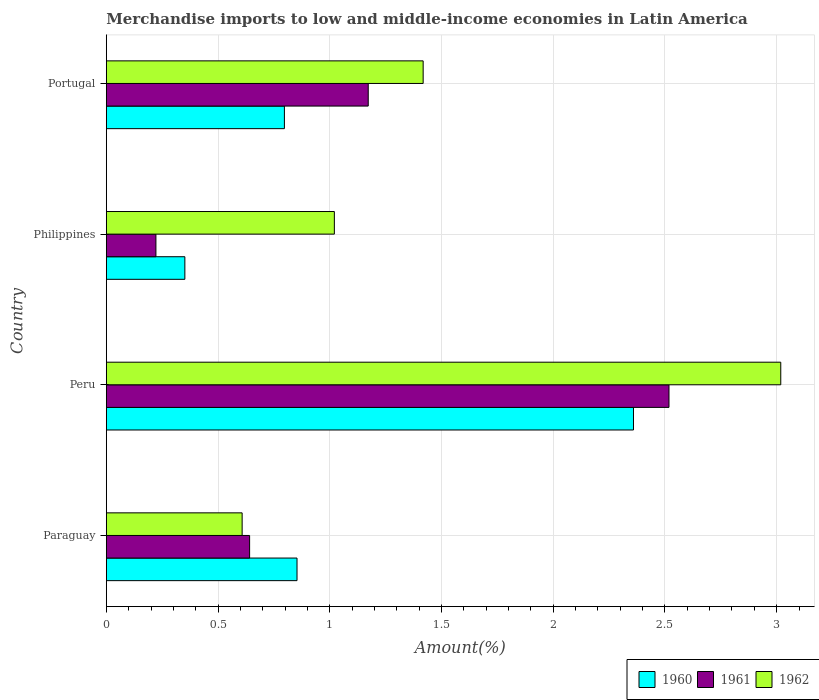Are the number of bars per tick equal to the number of legend labels?
Offer a very short reply. Yes. How many bars are there on the 1st tick from the bottom?
Provide a short and direct response. 3. In how many cases, is the number of bars for a given country not equal to the number of legend labels?
Provide a succinct answer. 0. What is the percentage of amount earned from merchandise imports in 1962 in Peru?
Give a very brief answer. 3.02. Across all countries, what is the maximum percentage of amount earned from merchandise imports in 1961?
Your answer should be compact. 2.52. Across all countries, what is the minimum percentage of amount earned from merchandise imports in 1960?
Your answer should be very brief. 0.35. What is the total percentage of amount earned from merchandise imports in 1961 in the graph?
Provide a succinct answer. 4.55. What is the difference between the percentage of amount earned from merchandise imports in 1961 in Philippines and that in Portugal?
Your answer should be compact. -0.95. What is the difference between the percentage of amount earned from merchandise imports in 1961 in Peru and the percentage of amount earned from merchandise imports in 1960 in Paraguay?
Provide a short and direct response. 1.66. What is the average percentage of amount earned from merchandise imports in 1960 per country?
Provide a succinct answer. 1.09. What is the difference between the percentage of amount earned from merchandise imports in 1961 and percentage of amount earned from merchandise imports in 1962 in Portugal?
Keep it short and to the point. -0.25. What is the ratio of the percentage of amount earned from merchandise imports in 1960 in Paraguay to that in Peru?
Make the answer very short. 0.36. What is the difference between the highest and the second highest percentage of amount earned from merchandise imports in 1960?
Keep it short and to the point. 1.51. What is the difference between the highest and the lowest percentage of amount earned from merchandise imports in 1961?
Your response must be concise. 2.3. In how many countries, is the percentage of amount earned from merchandise imports in 1962 greater than the average percentage of amount earned from merchandise imports in 1962 taken over all countries?
Offer a very short reply. 1. What does the 1st bar from the top in Philippines represents?
Offer a very short reply. 1962. What does the 1st bar from the bottom in Portugal represents?
Provide a succinct answer. 1960. Is it the case that in every country, the sum of the percentage of amount earned from merchandise imports in 1960 and percentage of amount earned from merchandise imports in 1961 is greater than the percentage of amount earned from merchandise imports in 1962?
Offer a very short reply. No. Are all the bars in the graph horizontal?
Make the answer very short. Yes. How many countries are there in the graph?
Make the answer very short. 4. What is the difference between two consecutive major ticks on the X-axis?
Provide a succinct answer. 0.5. Are the values on the major ticks of X-axis written in scientific E-notation?
Give a very brief answer. No. Where does the legend appear in the graph?
Provide a short and direct response. Bottom right. What is the title of the graph?
Make the answer very short. Merchandise imports to low and middle-income economies in Latin America. What is the label or title of the X-axis?
Make the answer very short. Amount(%). What is the label or title of the Y-axis?
Make the answer very short. Country. What is the Amount(%) in 1960 in Paraguay?
Offer a terse response. 0.85. What is the Amount(%) in 1961 in Paraguay?
Your answer should be very brief. 0.64. What is the Amount(%) in 1962 in Paraguay?
Make the answer very short. 0.61. What is the Amount(%) in 1960 in Peru?
Your answer should be very brief. 2.36. What is the Amount(%) in 1961 in Peru?
Your answer should be compact. 2.52. What is the Amount(%) in 1962 in Peru?
Offer a very short reply. 3.02. What is the Amount(%) in 1960 in Philippines?
Your response must be concise. 0.35. What is the Amount(%) of 1961 in Philippines?
Give a very brief answer. 0.22. What is the Amount(%) in 1962 in Philippines?
Make the answer very short. 1.02. What is the Amount(%) of 1960 in Portugal?
Provide a short and direct response. 0.8. What is the Amount(%) in 1961 in Portugal?
Make the answer very short. 1.17. What is the Amount(%) of 1962 in Portugal?
Your answer should be compact. 1.42. Across all countries, what is the maximum Amount(%) of 1960?
Your answer should be compact. 2.36. Across all countries, what is the maximum Amount(%) of 1961?
Keep it short and to the point. 2.52. Across all countries, what is the maximum Amount(%) in 1962?
Offer a very short reply. 3.02. Across all countries, what is the minimum Amount(%) of 1960?
Give a very brief answer. 0.35. Across all countries, what is the minimum Amount(%) of 1961?
Your response must be concise. 0.22. Across all countries, what is the minimum Amount(%) in 1962?
Your response must be concise. 0.61. What is the total Amount(%) of 1960 in the graph?
Provide a succinct answer. 4.36. What is the total Amount(%) of 1961 in the graph?
Provide a succinct answer. 4.55. What is the total Amount(%) of 1962 in the graph?
Make the answer very short. 6.06. What is the difference between the Amount(%) of 1960 in Paraguay and that in Peru?
Give a very brief answer. -1.51. What is the difference between the Amount(%) of 1961 in Paraguay and that in Peru?
Offer a terse response. -1.88. What is the difference between the Amount(%) in 1962 in Paraguay and that in Peru?
Make the answer very short. -2.41. What is the difference between the Amount(%) of 1960 in Paraguay and that in Philippines?
Your response must be concise. 0.5. What is the difference between the Amount(%) in 1961 in Paraguay and that in Philippines?
Your answer should be compact. 0.42. What is the difference between the Amount(%) of 1962 in Paraguay and that in Philippines?
Make the answer very short. -0.41. What is the difference between the Amount(%) in 1960 in Paraguay and that in Portugal?
Keep it short and to the point. 0.06. What is the difference between the Amount(%) in 1961 in Paraguay and that in Portugal?
Give a very brief answer. -0.53. What is the difference between the Amount(%) of 1962 in Paraguay and that in Portugal?
Your answer should be compact. -0.81. What is the difference between the Amount(%) of 1960 in Peru and that in Philippines?
Your answer should be compact. 2.01. What is the difference between the Amount(%) in 1961 in Peru and that in Philippines?
Give a very brief answer. 2.3. What is the difference between the Amount(%) in 1962 in Peru and that in Philippines?
Provide a short and direct response. 2. What is the difference between the Amount(%) of 1960 in Peru and that in Portugal?
Your response must be concise. 1.56. What is the difference between the Amount(%) of 1961 in Peru and that in Portugal?
Offer a very short reply. 1.35. What is the difference between the Amount(%) of 1962 in Peru and that in Portugal?
Your answer should be very brief. 1.6. What is the difference between the Amount(%) in 1960 in Philippines and that in Portugal?
Offer a very short reply. -0.45. What is the difference between the Amount(%) in 1961 in Philippines and that in Portugal?
Your answer should be compact. -0.95. What is the difference between the Amount(%) in 1962 in Philippines and that in Portugal?
Give a very brief answer. -0.4. What is the difference between the Amount(%) of 1960 in Paraguay and the Amount(%) of 1961 in Peru?
Provide a succinct answer. -1.66. What is the difference between the Amount(%) of 1960 in Paraguay and the Amount(%) of 1962 in Peru?
Offer a terse response. -2.17. What is the difference between the Amount(%) of 1961 in Paraguay and the Amount(%) of 1962 in Peru?
Keep it short and to the point. -2.38. What is the difference between the Amount(%) of 1960 in Paraguay and the Amount(%) of 1961 in Philippines?
Your answer should be very brief. 0.63. What is the difference between the Amount(%) of 1960 in Paraguay and the Amount(%) of 1962 in Philippines?
Offer a very short reply. -0.17. What is the difference between the Amount(%) in 1961 in Paraguay and the Amount(%) in 1962 in Philippines?
Give a very brief answer. -0.38. What is the difference between the Amount(%) in 1960 in Paraguay and the Amount(%) in 1961 in Portugal?
Make the answer very short. -0.32. What is the difference between the Amount(%) of 1960 in Paraguay and the Amount(%) of 1962 in Portugal?
Ensure brevity in your answer.  -0.56. What is the difference between the Amount(%) in 1961 in Paraguay and the Amount(%) in 1962 in Portugal?
Make the answer very short. -0.78. What is the difference between the Amount(%) in 1960 in Peru and the Amount(%) in 1961 in Philippines?
Your answer should be compact. 2.14. What is the difference between the Amount(%) of 1960 in Peru and the Amount(%) of 1962 in Philippines?
Your answer should be compact. 1.34. What is the difference between the Amount(%) of 1961 in Peru and the Amount(%) of 1962 in Philippines?
Offer a very short reply. 1.5. What is the difference between the Amount(%) of 1960 in Peru and the Amount(%) of 1961 in Portugal?
Your answer should be compact. 1.19. What is the difference between the Amount(%) in 1960 in Peru and the Amount(%) in 1962 in Portugal?
Make the answer very short. 0.94. What is the difference between the Amount(%) of 1961 in Peru and the Amount(%) of 1962 in Portugal?
Give a very brief answer. 1.1. What is the difference between the Amount(%) in 1960 in Philippines and the Amount(%) in 1961 in Portugal?
Provide a short and direct response. -0.82. What is the difference between the Amount(%) in 1960 in Philippines and the Amount(%) in 1962 in Portugal?
Ensure brevity in your answer.  -1.07. What is the difference between the Amount(%) in 1961 in Philippines and the Amount(%) in 1962 in Portugal?
Offer a very short reply. -1.2. What is the average Amount(%) of 1960 per country?
Make the answer very short. 1.09. What is the average Amount(%) of 1961 per country?
Your answer should be very brief. 1.14. What is the average Amount(%) of 1962 per country?
Ensure brevity in your answer.  1.52. What is the difference between the Amount(%) of 1960 and Amount(%) of 1961 in Paraguay?
Your response must be concise. 0.21. What is the difference between the Amount(%) of 1960 and Amount(%) of 1962 in Paraguay?
Offer a very short reply. 0.25. What is the difference between the Amount(%) in 1961 and Amount(%) in 1962 in Paraguay?
Provide a short and direct response. 0.03. What is the difference between the Amount(%) of 1960 and Amount(%) of 1961 in Peru?
Offer a very short reply. -0.16. What is the difference between the Amount(%) of 1960 and Amount(%) of 1962 in Peru?
Your answer should be very brief. -0.66. What is the difference between the Amount(%) of 1961 and Amount(%) of 1962 in Peru?
Keep it short and to the point. -0.5. What is the difference between the Amount(%) of 1960 and Amount(%) of 1961 in Philippines?
Your answer should be very brief. 0.13. What is the difference between the Amount(%) of 1960 and Amount(%) of 1962 in Philippines?
Offer a terse response. -0.67. What is the difference between the Amount(%) of 1961 and Amount(%) of 1962 in Philippines?
Your answer should be very brief. -0.8. What is the difference between the Amount(%) in 1960 and Amount(%) in 1961 in Portugal?
Your response must be concise. -0.38. What is the difference between the Amount(%) in 1960 and Amount(%) in 1962 in Portugal?
Give a very brief answer. -0.62. What is the difference between the Amount(%) in 1961 and Amount(%) in 1962 in Portugal?
Make the answer very short. -0.25. What is the ratio of the Amount(%) in 1960 in Paraguay to that in Peru?
Offer a terse response. 0.36. What is the ratio of the Amount(%) of 1961 in Paraguay to that in Peru?
Provide a succinct answer. 0.25. What is the ratio of the Amount(%) of 1962 in Paraguay to that in Peru?
Your answer should be very brief. 0.2. What is the ratio of the Amount(%) of 1960 in Paraguay to that in Philippines?
Your response must be concise. 2.43. What is the ratio of the Amount(%) in 1961 in Paraguay to that in Philippines?
Your answer should be compact. 2.89. What is the ratio of the Amount(%) of 1962 in Paraguay to that in Philippines?
Ensure brevity in your answer.  0.6. What is the ratio of the Amount(%) of 1960 in Paraguay to that in Portugal?
Give a very brief answer. 1.07. What is the ratio of the Amount(%) in 1961 in Paraguay to that in Portugal?
Your answer should be compact. 0.55. What is the ratio of the Amount(%) in 1962 in Paraguay to that in Portugal?
Your answer should be very brief. 0.43. What is the ratio of the Amount(%) in 1960 in Peru to that in Philippines?
Ensure brevity in your answer.  6.71. What is the ratio of the Amount(%) of 1961 in Peru to that in Philippines?
Make the answer very short. 11.35. What is the ratio of the Amount(%) of 1962 in Peru to that in Philippines?
Your response must be concise. 2.96. What is the ratio of the Amount(%) in 1960 in Peru to that in Portugal?
Make the answer very short. 2.96. What is the ratio of the Amount(%) in 1961 in Peru to that in Portugal?
Make the answer very short. 2.15. What is the ratio of the Amount(%) of 1962 in Peru to that in Portugal?
Keep it short and to the point. 2.13. What is the ratio of the Amount(%) of 1960 in Philippines to that in Portugal?
Offer a terse response. 0.44. What is the ratio of the Amount(%) of 1961 in Philippines to that in Portugal?
Give a very brief answer. 0.19. What is the ratio of the Amount(%) of 1962 in Philippines to that in Portugal?
Give a very brief answer. 0.72. What is the difference between the highest and the second highest Amount(%) in 1960?
Ensure brevity in your answer.  1.51. What is the difference between the highest and the second highest Amount(%) in 1961?
Offer a terse response. 1.35. What is the difference between the highest and the second highest Amount(%) in 1962?
Your answer should be very brief. 1.6. What is the difference between the highest and the lowest Amount(%) in 1960?
Offer a very short reply. 2.01. What is the difference between the highest and the lowest Amount(%) of 1961?
Your answer should be very brief. 2.3. What is the difference between the highest and the lowest Amount(%) in 1962?
Make the answer very short. 2.41. 